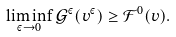Convert formula to latex. <formula><loc_0><loc_0><loc_500><loc_500>\liminf _ { \varepsilon \rightarrow 0 } \mathcal { G } ^ { \varepsilon } ( v ^ { \varepsilon } ) \geq \mathcal { F } ^ { 0 } ( v ) .</formula> 